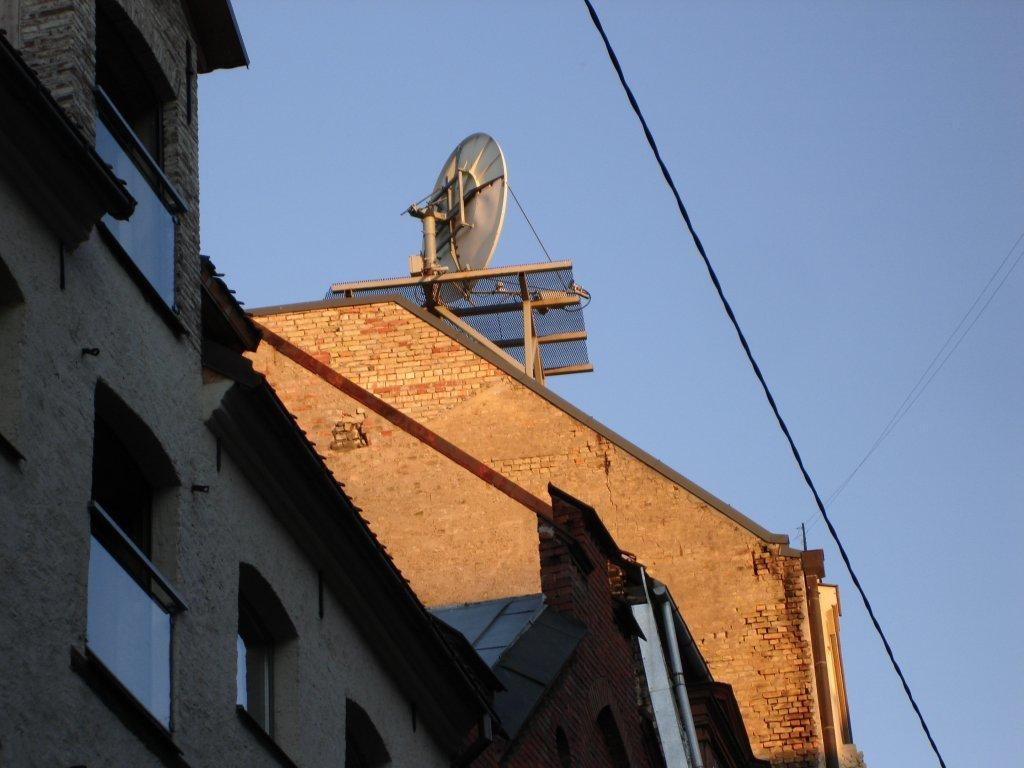What type of structures can be seen in the image? There are buildings in the image. What else is present in the image besides the buildings? There are wires and an antenna on one of the buildings. What can be seen in the background of the image? The sky is visible in the background of the image. What type of beef is being cooked in the image? There is no beef present in the image; it features buildings, wires, and an antenna. Can you describe the woman in the image? There is no woman present in the image. 